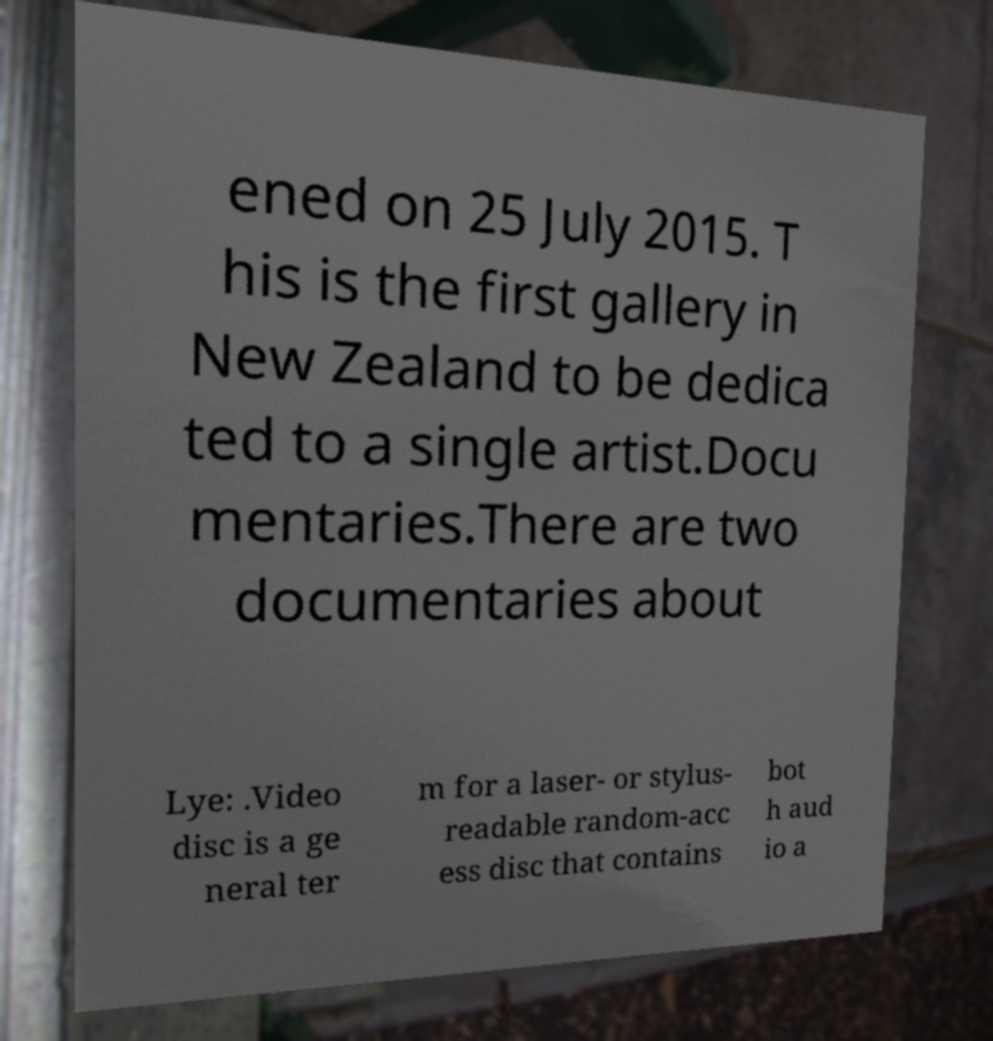There's text embedded in this image that I need extracted. Can you transcribe it verbatim? ened on 25 July 2015. T his is the first gallery in New Zealand to be dedica ted to a single artist.Docu mentaries.There are two documentaries about Lye: .Video disc is a ge neral ter m for a laser- or stylus- readable random-acc ess disc that contains bot h aud io a 